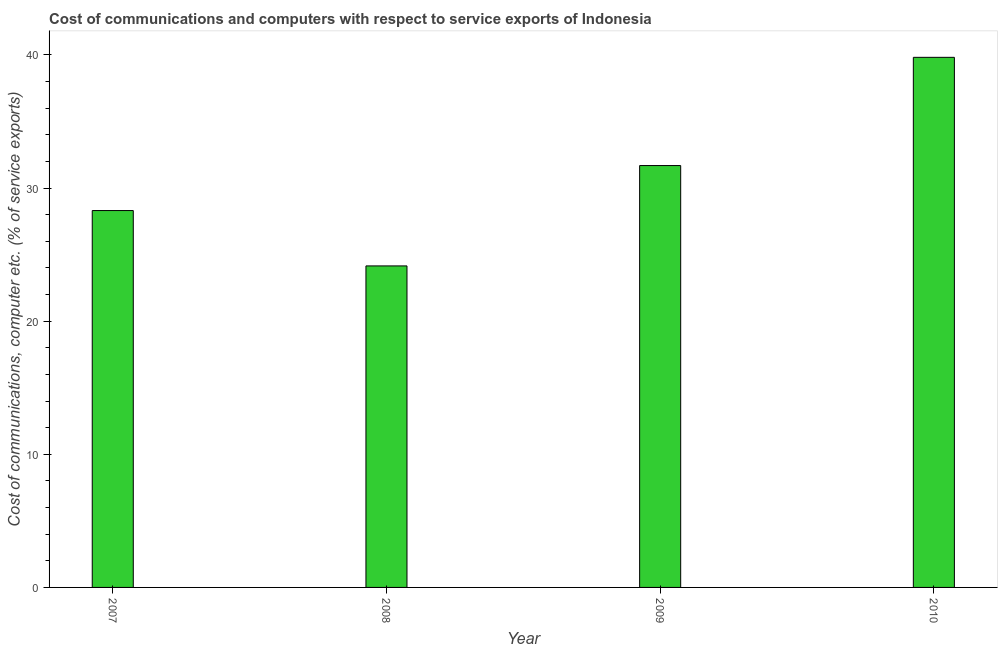Does the graph contain any zero values?
Ensure brevity in your answer.  No. What is the title of the graph?
Make the answer very short. Cost of communications and computers with respect to service exports of Indonesia. What is the label or title of the Y-axis?
Provide a succinct answer. Cost of communications, computer etc. (% of service exports). What is the cost of communications and computer in 2007?
Provide a short and direct response. 28.31. Across all years, what is the maximum cost of communications and computer?
Provide a succinct answer. 39.81. Across all years, what is the minimum cost of communications and computer?
Ensure brevity in your answer.  24.15. In which year was the cost of communications and computer minimum?
Your answer should be very brief. 2008. What is the sum of the cost of communications and computer?
Give a very brief answer. 123.95. What is the difference between the cost of communications and computer in 2008 and 2009?
Keep it short and to the point. -7.54. What is the average cost of communications and computer per year?
Offer a very short reply. 30.99. What is the median cost of communications and computer?
Your response must be concise. 30. Do a majority of the years between 2008 and 2010 (inclusive) have cost of communications and computer greater than 36 %?
Your answer should be compact. No. What is the ratio of the cost of communications and computer in 2009 to that in 2010?
Provide a succinct answer. 0.8. What is the difference between the highest and the second highest cost of communications and computer?
Offer a very short reply. 8.13. Is the sum of the cost of communications and computer in 2007 and 2008 greater than the maximum cost of communications and computer across all years?
Provide a succinct answer. Yes. What is the difference between the highest and the lowest cost of communications and computer?
Give a very brief answer. 15.67. In how many years, is the cost of communications and computer greater than the average cost of communications and computer taken over all years?
Your answer should be compact. 2. How many bars are there?
Your answer should be compact. 4. How many years are there in the graph?
Ensure brevity in your answer.  4. What is the difference between two consecutive major ticks on the Y-axis?
Ensure brevity in your answer.  10. What is the Cost of communications, computer etc. (% of service exports) in 2007?
Ensure brevity in your answer.  28.31. What is the Cost of communications, computer etc. (% of service exports) in 2008?
Ensure brevity in your answer.  24.15. What is the Cost of communications, computer etc. (% of service exports) of 2009?
Keep it short and to the point. 31.69. What is the Cost of communications, computer etc. (% of service exports) in 2010?
Make the answer very short. 39.81. What is the difference between the Cost of communications, computer etc. (% of service exports) in 2007 and 2008?
Make the answer very short. 4.16. What is the difference between the Cost of communications, computer etc. (% of service exports) in 2007 and 2009?
Provide a succinct answer. -3.38. What is the difference between the Cost of communications, computer etc. (% of service exports) in 2007 and 2010?
Give a very brief answer. -11.51. What is the difference between the Cost of communications, computer etc. (% of service exports) in 2008 and 2009?
Offer a terse response. -7.54. What is the difference between the Cost of communications, computer etc. (% of service exports) in 2008 and 2010?
Offer a very short reply. -15.67. What is the difference between the Cost of communications, computer etc. (% of service exports) in 2009 and 2010?
Ensure brevity in your answer.  -8.13. What is the ratio of the Cost of communications, computer etc. (% of service exports) in 2007 to that in 2008?
Your answer should be compact. 1.17. What is the ratio of the Cost of communications, computer etc. (% of service exports) in 2007 to that in 2009?
Your answer should be compact. 0.89. What is the ratio of the Cost of communications, computer etc. (% of service exports) in 2007 to that in 2010?
Provide a succinct answer. 0.71. What is the ratio of the Cost of communications, computer etc. (% of service exports) in 2008 to that in 2009?
Offer a very short reply. 0.76. What is the ratio of the Cost of communications, computer etc. (% of service exports) in 2008 to that in 2010?
Provide a succinct answer. 0.61. What is the ratio of the Cost of communications, computer etc. (% of service exports) in 2009 to that in 2010?
Give a very brief answer. 0.8. 